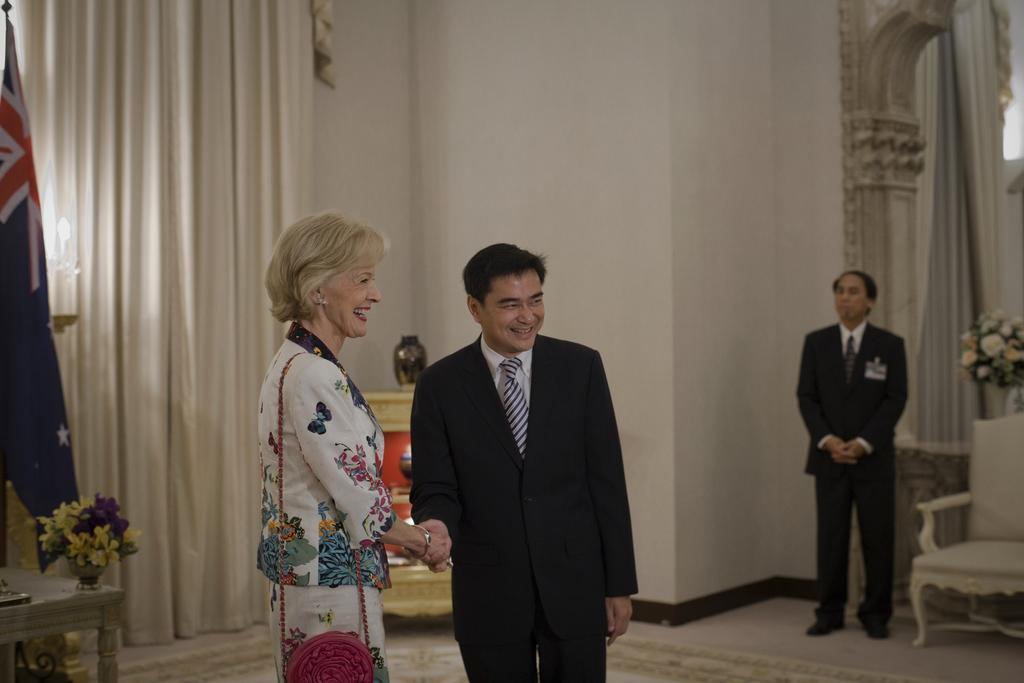Can you describe this image briefly? In this picture we can see three persons standing on the floor. This is chair. And there is a flower vase on the table. And this is flag. Here we can see a curtain. On the background there is a wall. 